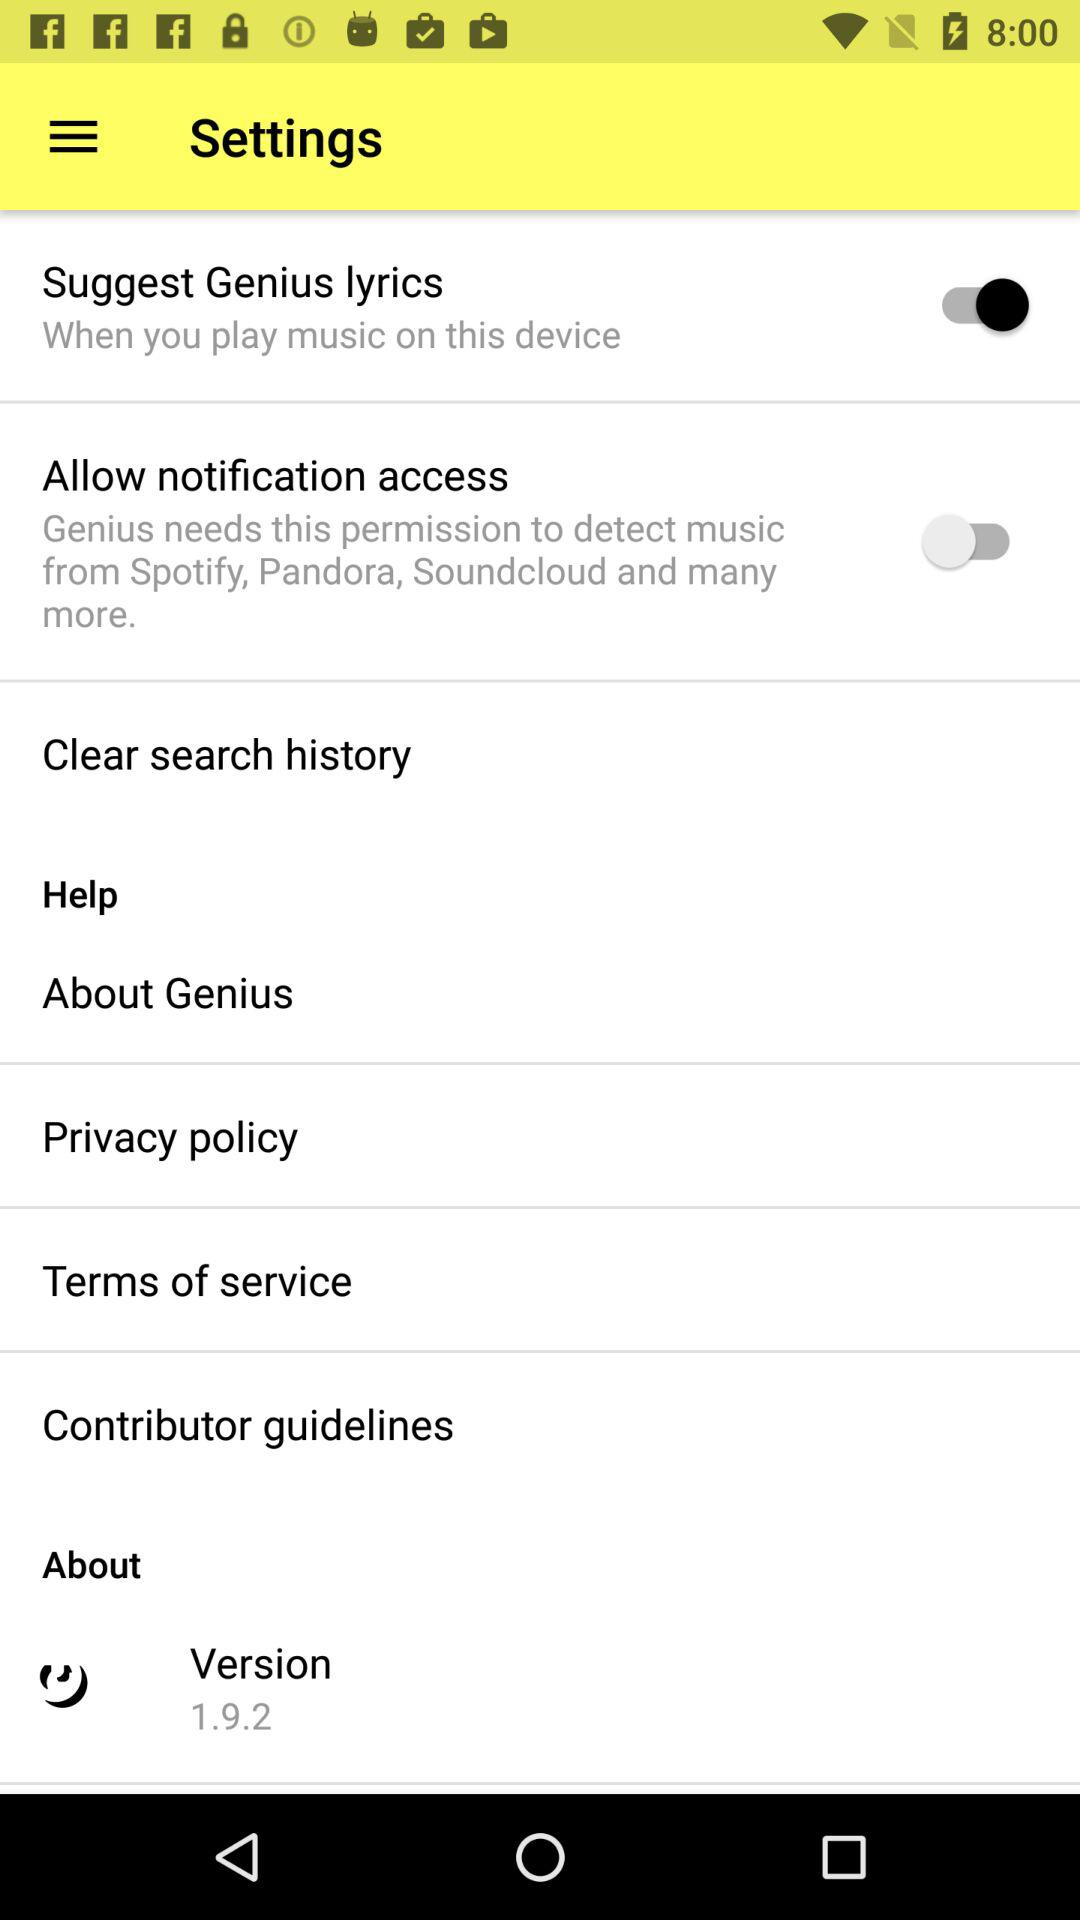What is the current status of the "Allow notification access"? The status is "off". 